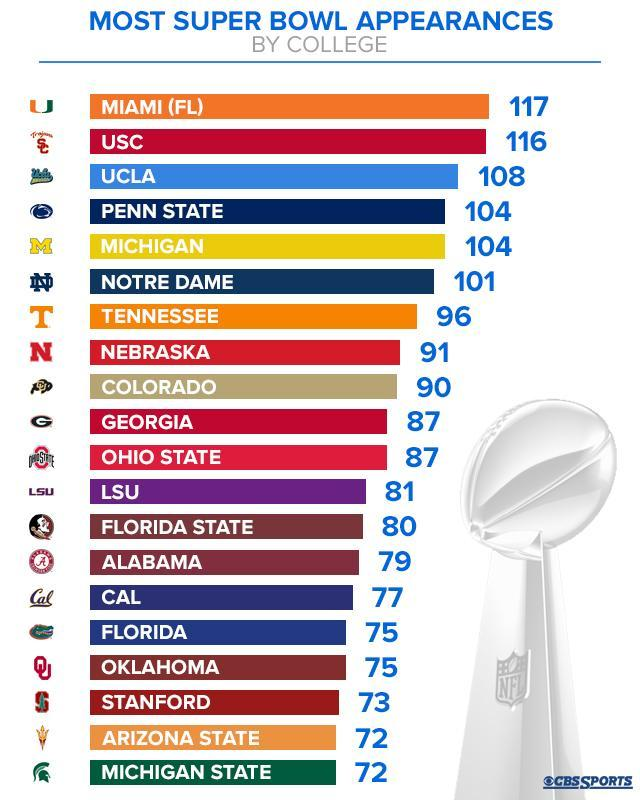which college has made the third highest number of super bowl appearances?
Answer the question with a short phrase. UCLA How many colleges have made 100 or more super bowl appearances? 6 How many colleges have made 104 super bowl appearances? 2 The name of which college is mentioned in the second last row of the list? Arizona State How many colleges have been listed in this infographic? 20 How many colleges have made less than 85 super bowl appearances? 9 How many super bowl appearances were made by the 10th college in the list? 87 The name of which college is mentioned 7th in the list? Tennessee 